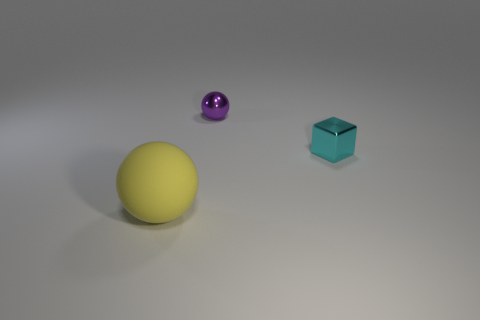Add 2 small shiny spheres. How many objects exist? 5 Subtract all blocks. How many objects are left? 2 Add 3 purple spheres. How many purple spheres are left? 4 Add 2 yellow matte spheres. How many yellow matte spheres exist? 3 Subtract 0 green cylinders. How many objects are left? 3 Subtract all metallic blocks. Subtract all tiny yellow spheres. How many objects are left? 2 